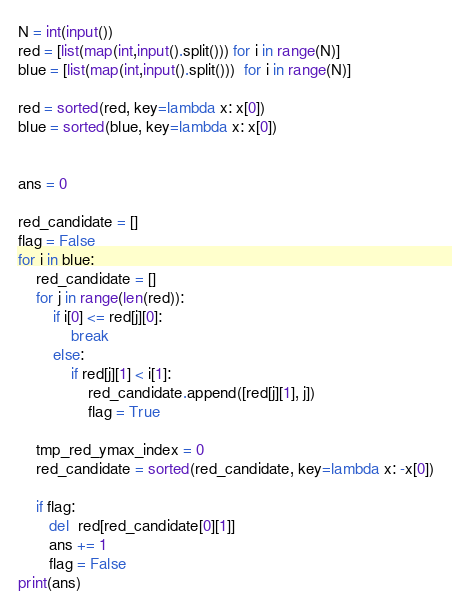Convert code to text. <code><loc_0><loc_0><loc_500><loc_500><_Python_>N = int(input())
red = [list(map(int,input().split())) for i in range(N)]
blue = [list(map(int,input().split()))  for i in range(N)]

red = sorted(red, key=lambda x: x[0])
blue = sorted(blue, key=lambda x: x[0])


ans = 0

red_candidate = []
flag = False
for i in blue:
    red_candidate = []
    for j in range(len(red)):
        if i[0] <= red[j][0]:
            break
        else:
            if red[j][1] < i[1]:
                red_candidate.append([red[j][1], j])
                flag = True

    tmp_red_ymax_index = 0
    red_candidate = sorted(red_candidate, key=lambda x: -x[0])

    if flag:
       del  red[red_candidate[0][1]] 
       ans += 1
       flag = False
print(ans)</code> 